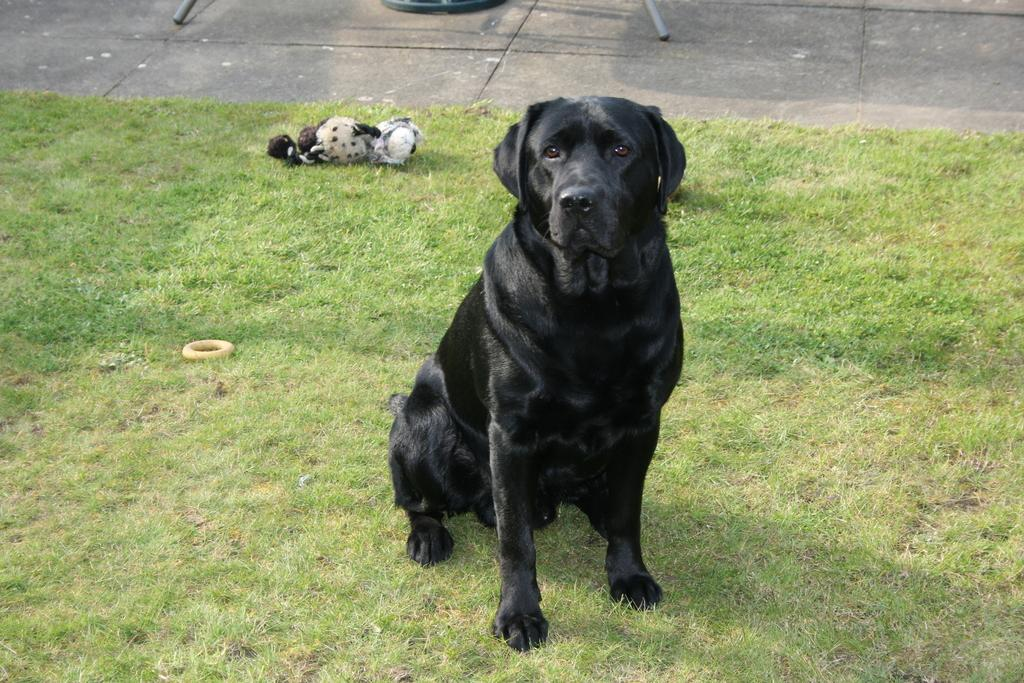What type of vegetation is present in the image? There is grass in the image. What animal can be seen in the image? There is a black dog in the image. Can you describe the background of the image? There are objects in the background of the image. How many snails are crawling on the black dog in the image? There are no snails present in the image, so it is not possible to answer that question. 